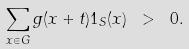<formula> <loc_0><loc_0><loc_500><loc_500>\sum _ { x \in G } g ( x + t ) 1 _ { S } ( x ) \ > \ 0 .</formula> 